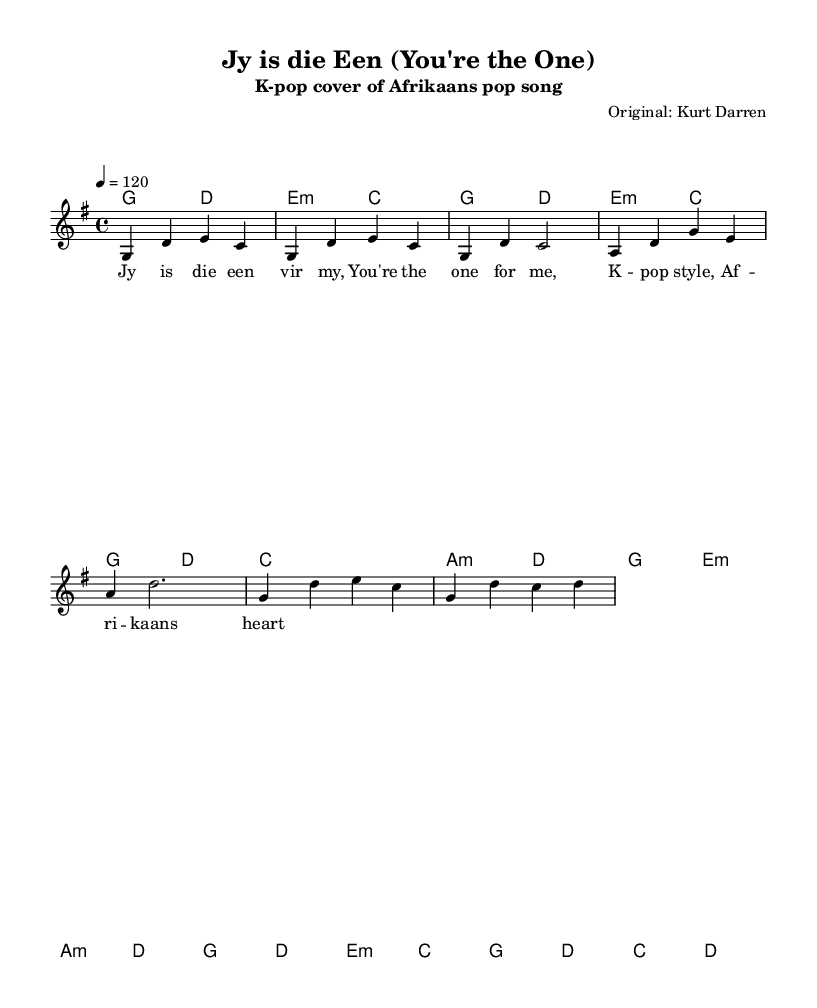What is the key signature of this music? The key signature is G major, which has one sharp (F#). You can identify this by looking at the left side of the staff where the sharps or flats are indicated.
Answer: G major What is the time signature of this piece? The time signature is 4/4, shown at the beginning of the staff. This means there are four beats in each measure and a quarter note gets one beat.
Answer: 4/4 What is the tempo marking indicated in the music? The tempo marking is 120, found under the tempo indication at the beginning. This means the piece should be played at a speed of 120 beats per minute.
Answer: 120 How many measures are in the chorus section? The chorus consists of four measures, which can be counted by looking at the grouped notes marked in that section.
Answer: four Which languages are used in the lyrics? The lyrics include both Afrikaans and English, as evidenced by the phrase structure and the specific lyrics printed under the staff.
Answer: Afrikaans and English What chord is used in the pre-chorus section? The pre-chorus section primarily uses the A minor chord in the first measure, as indicated by the chord symbols present at the start of that section.
Answer: A minor What style is this sheet music adapted to? The music is adapted to K-pop style, which is noted in the subtitle of the header, indicating the type of arrangement and genre.
Answer: K-pop 